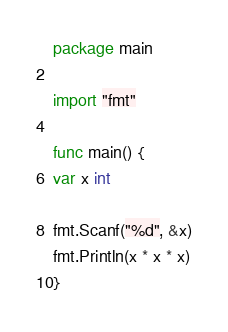Convert code to text. <code><loc_0><loc_0><loc_500><loc_500><_Go_>package main

import "fmt"

func main() {
var x int 

fmt.Scanf("%d", &x)
fmt.Println(x * x * x)
}
</code> 